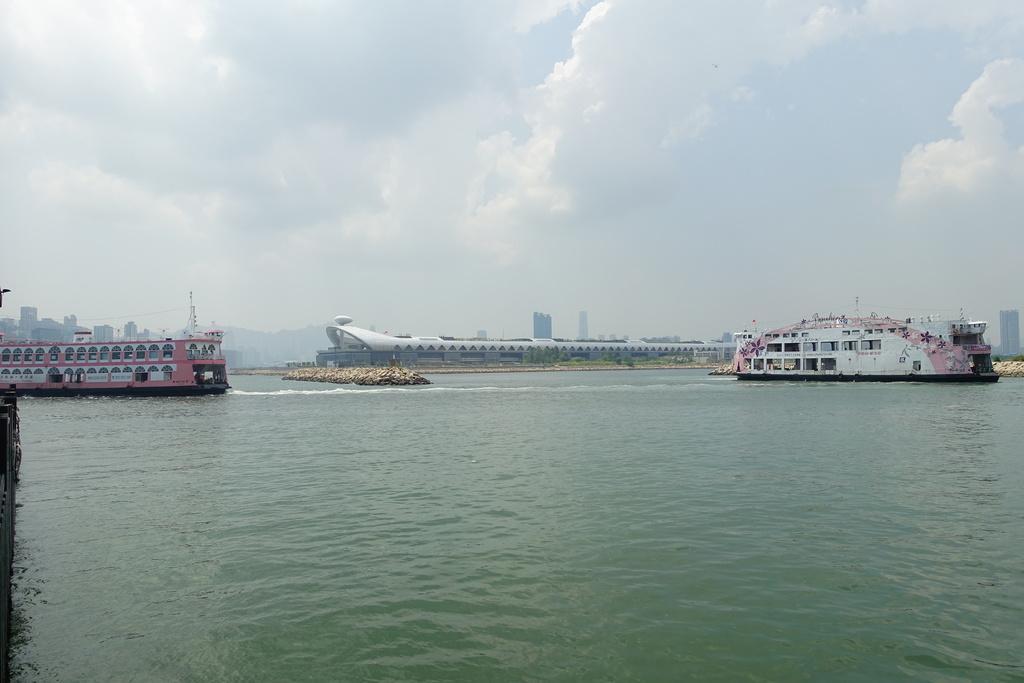Can you describe this image briefly? In this picture I can observe two ships floating on the water. In the middle of the picture I can observe a river. In the background there are some clouds in the sky. 